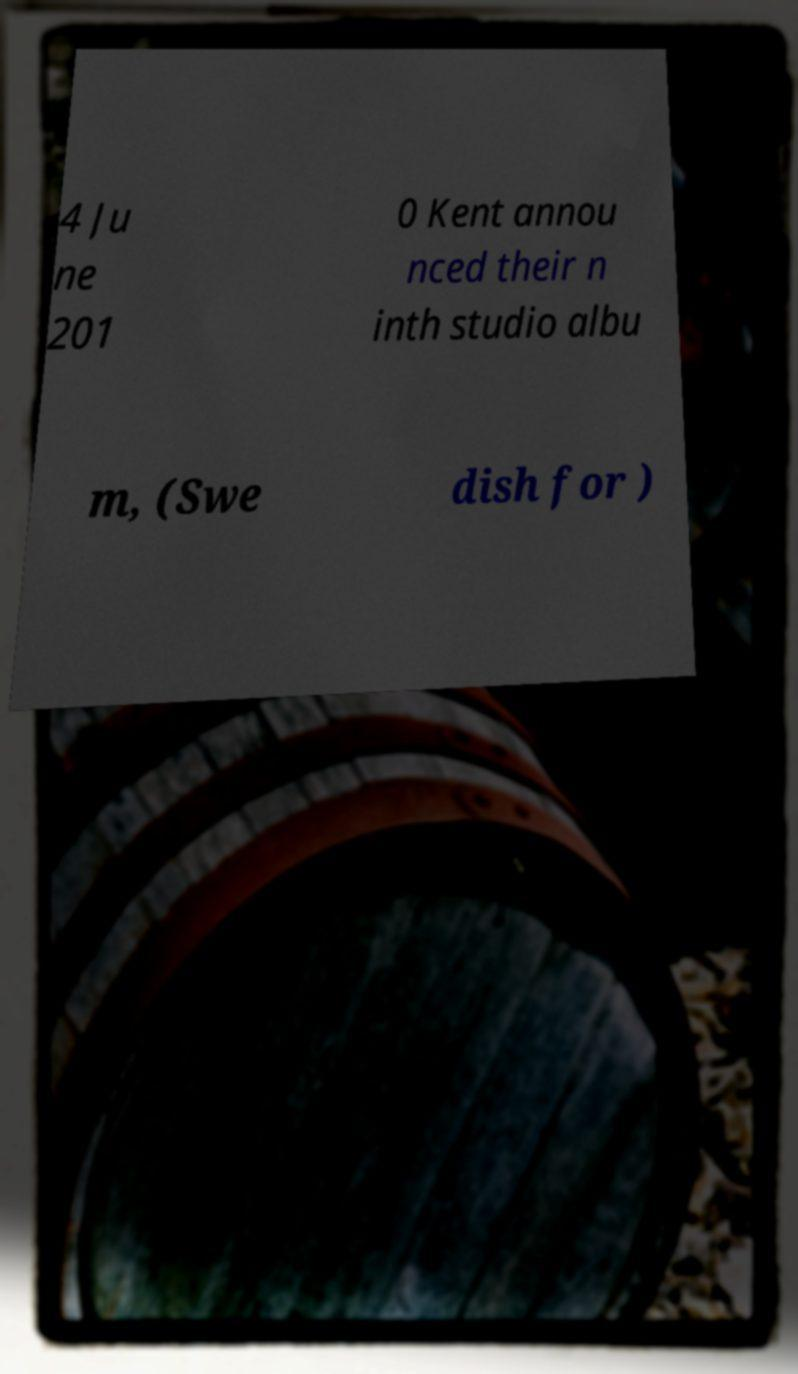I need the written content from this picture converted into text. Can you do that? 4 Ju ne 201 0 Kent annou nced their n inth studio albu m, (Swe dish for ) 